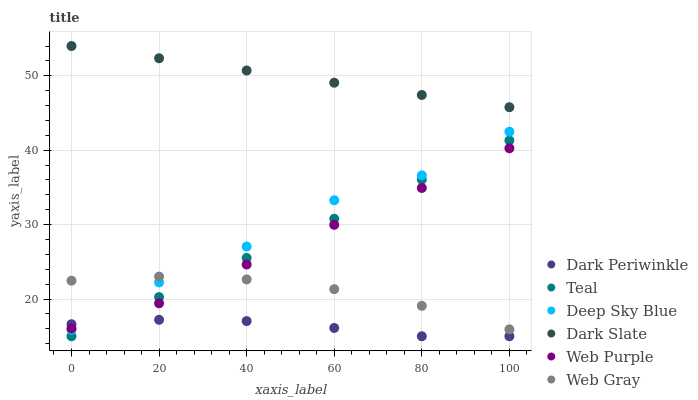Does Dark Periwinkle have the minimum area under the curve?
Answer yes or no. Yes. Does Dark Slate have the maximum area under the curve?
Answer yes or no. Yes. Does Teal have the minimum area under the curve?
Answer yes or no. No. Does Teal have the maximum area under the curve?
Answer yes or no. No. Is Dark Slate the smoothest?
Answer yes or no. Yes. Is Deep Sky Blue the roughest?
Answer yes or no. Yes. Is Teal the smoothest?
Answer yes or no. No. Is Teal the roughest?
Answer yes or no. No. Does Teal have the lowest value?
Answer yes or no. Yes. Does Dark Slate have the lowest value?
Answer yes or no. No. Does Dark Slate have the highest value?
Answer yes or no. Yes. Does Teal have the highest value?
Answer yes or no. No. Is Web Gray less than Dark Slate?
Answer yes or no. Yes. Is Dark Slate greater than Web Purple?
Answer yes or no. Yes. Does Teal intersect Web Purple?
Answer yes or no. Yes. Is Teal less than Web Purple?
Answer yes or no. No. Is Teal greater than Web Purple?
Answer yes or no. No. Does Web Gray intersect Dark Slate?
Answer yes or no. No. 